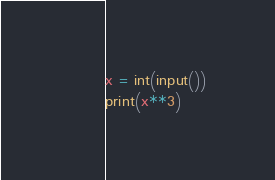<code> <loc_0><loc_0><loc_500><loc_500><_Python_>x = int(input())
print(x**3)

</code> 